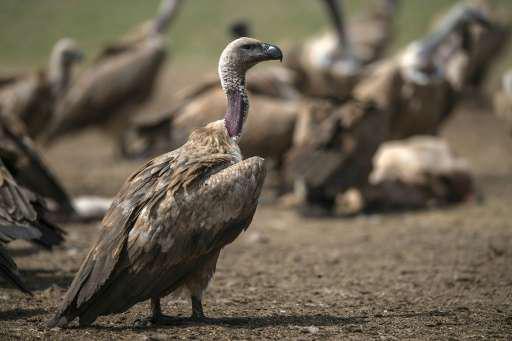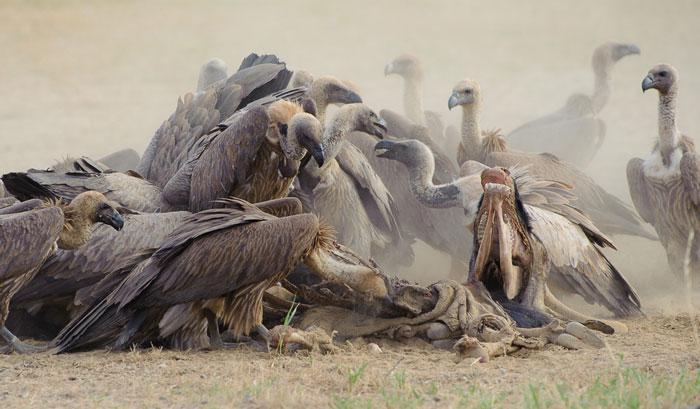The first image is the image on the left, the second image is the image on the right. Assess this claim about the two images: "there is at least one image with a vulture with wings spread". Correct or not? Answer yes or no. No. The first image is the image on the left, the second image is the image on the right. For the images shown, is this caption "In the image to the left, vultures feed." true? Answer yes or no. No. 